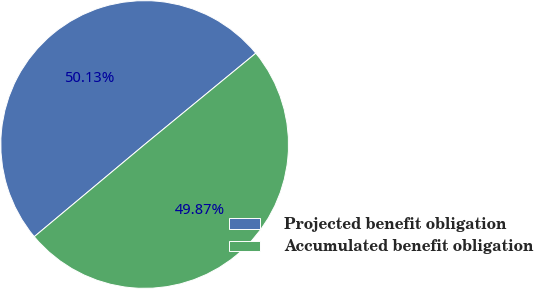Convert chart to OTSL. <chart><loc_0><loc_0><loc_500><loc_500><pie_chart><fcel>Projected benefit obligation<fcel>Accumulated benefit obligation<nl><fcel>50.13%<fcel>49.87%<nl></chart> 